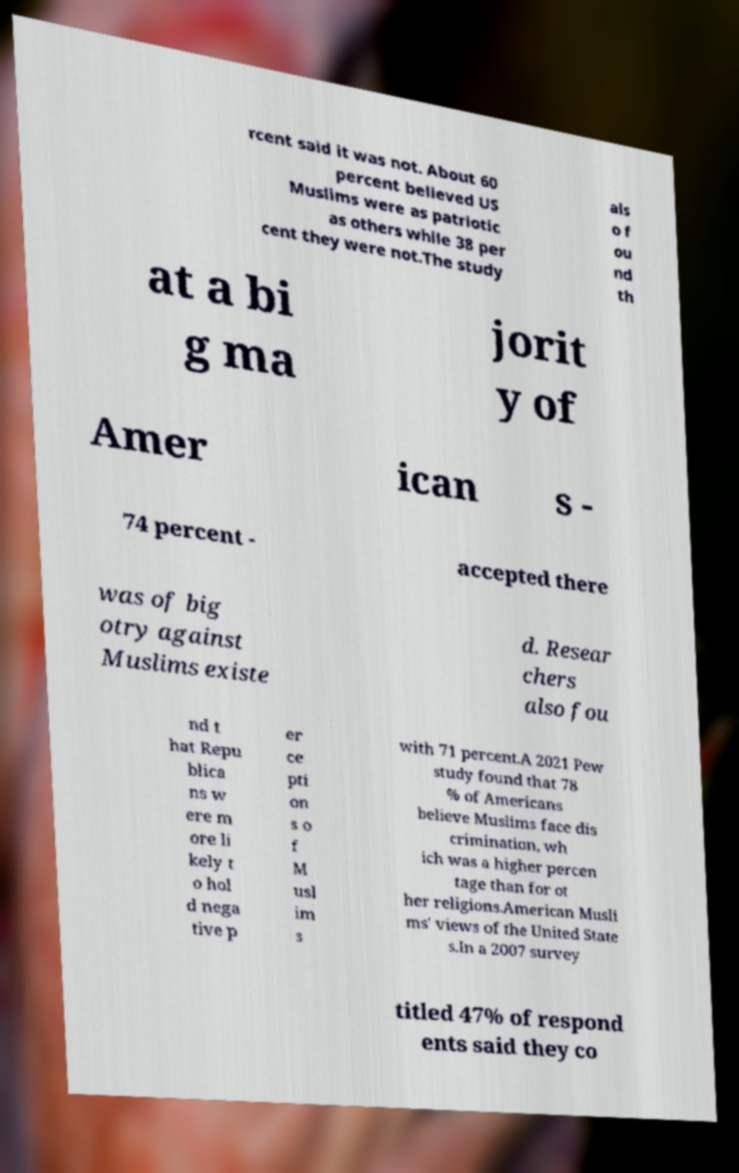Can you read and provide the text displayed in the image?This photo seems to have some interesting text. Can you extract and type it out for me? rcent said it was not. About 60 percent believed US Muslims were as patriotic as others while 38 per cent they were not.The study als o f ou nd th at a bi g ma jorit y of Amer ican s - 74 percent - accepted there was of big otry against Muslims existe d. Resear chers also fou nd t hat Repu blica ns w ere m ore li kely t o hol d nega tive p er ce pti on s o f M usl im s with 71 percent.A 2021 Pew study found that 78 % of Americans believe Muslims face dis crimination, wh ich was a higher percen tage than for ot her religions.American Musli ms' views of the United State s.In a 2007 survey titled 47% of respond ents said they co 